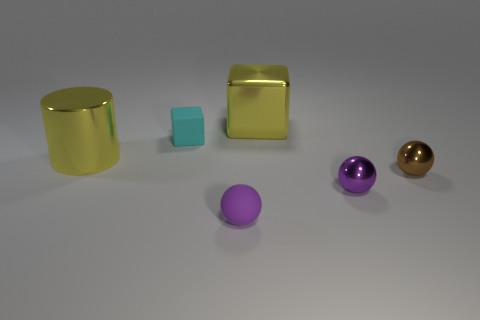What is the color of the other metallic object that is the same shape as the tiny brown thing?
Make the answer very short. Purple. Is the brown sphere the same size as the rubber cube?
Offer a very short reply. Yes. Is the number of things that are behind the tiny brown object the same as the number of things left of the large cube?
Make the answer very short. Yes. Are there any purple rubber objects?
Offer a terse response. Yes. There is a yellow thing that is the same shape as the cyan matte object; what is its size?
Give a very brief answer. Large. There is a purple object that is left of the large yellow cube; what is its size?
Your response must be concise. Small. Is the number of large yellow cylinders that are on the right side of the brown metallic ball greater than the number of tiny brown cylinders?
Offer a very short reply. No. What is the shape of the small cyan matte object?
Your response must be concise. Cube. Is the color of the small metal ball that is in front of the brown shiny object the same as the ball that is on the left side of the large yellow cube?
Offer a very short reply. Yes. Is the brown shiny thing the same shape as the small cyan object?
Your answer should be very brief. No. 